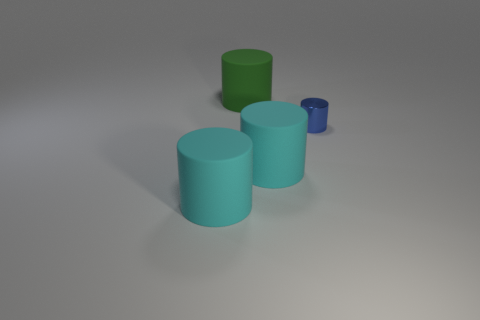Subtract all large matte cylinders. How many cylinders are left? 1 Subtract all green cylinders. How many cylinders are left? 3 Subtract 1 cylinders. How many cylinders are left? 3 Subtract all red cylinders. Subtract all green balls. How many cylinders are left? 4 Add 2 big matte things. How many objects exist? 6 Subtract 0 blue blocks. How many objects are left? 4 Subtract all large purple rubber balls. Subtract all cyan cylinders. How many objects are left? 2 Add 4 cyan rubber objects. How many cyan rubber objects are left? 6 Add 4 large green matte objects. How many large green matte objects exist? 5 